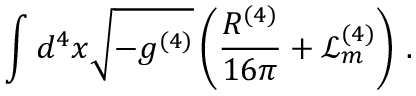<formula> <loc_0><loc_0><loc_500><loc_500>\int d ^ { 4 } x \sqrt { - g ^ { ( 4 ) } } \left ( \frac { R ^ { ( 4 ) } } { 1 6 \pi } + \mathcal { L } _ { m } ^ { ( 4 ) } \right ) \, .</formula> 